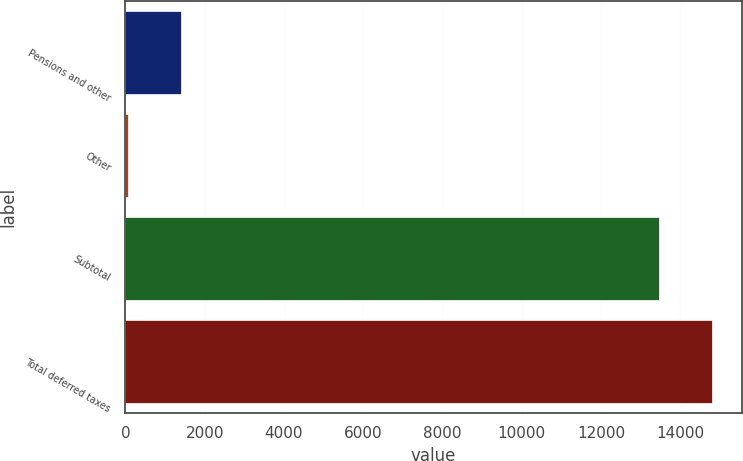Convert chart to OTSL. <chart><loc_0><loc_0><loc_500><loc_500><bar_chart><fcel>Pensions and other<fcel>Other<fcel>Subtotal<fcel>Total deferred taxes<nl><fcel>1399.46<fcel>58.4<fcel>13469<fcel>14810.1<nl></chart> 